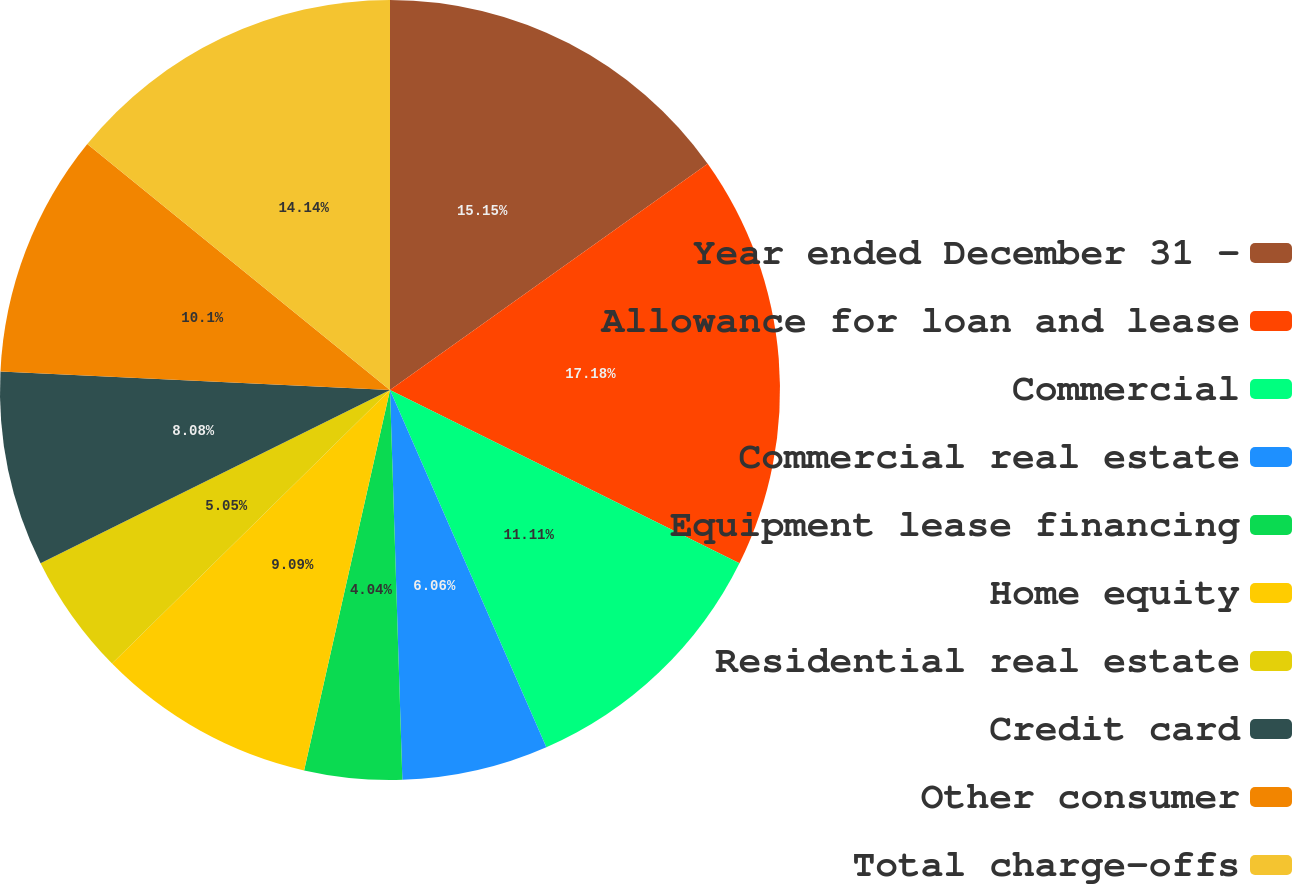<chart> <loc_0><loc_0><loc_500><loc_500><pie_chart><fcel>Year ended December 31 -<fcel>Allowance for loan and lease<fcel>Commercial<fcel>Commercial real estate<fcel>Equipment lease financing<fcel>Home equity<fcel>Residential real estate<fcel>Credit card<fcel>Other consumer<fcel>Total charge-offs<nl><fcel>15.15%<fcel>17.17%<fcel>11.11%<fcel>6.06%<fcel>4.04%<fcel>9.09%<fcel>5.05%<fcel>8.08%<fcel>10.1%<fcel>14.14%<nl></chart> 